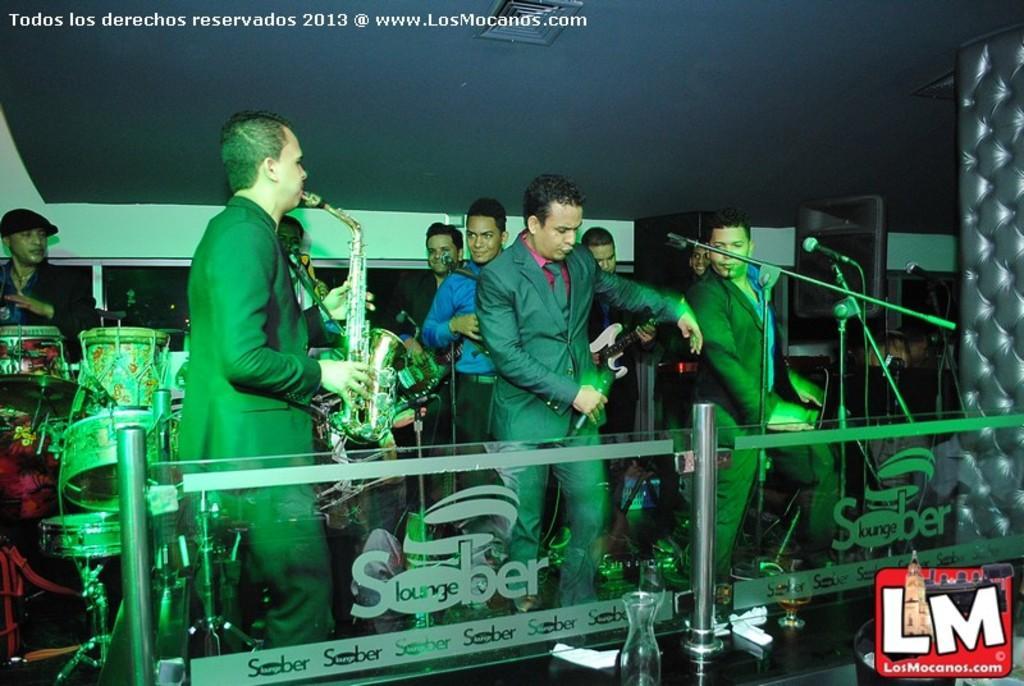How would you summarize this image in a sentence or two? In this picture there is a man in the center of the image, by holding mic in his hand and there is another man on the left side of the image he is playing trumpet and there are other people in the background area of the image, there is a drum set on the left side of the image and there is a desk at the bottom side of the image, which contains glasses on it. 